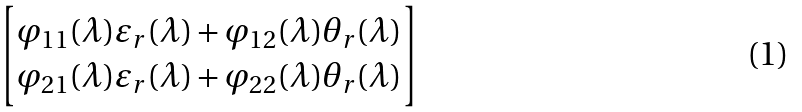Convert formula to latex. <formula><loc_0><loc_0><loc_500><loc_500>\begin{bmatrix} \varphi _ { 1 1 } ( \lambda ) \varepsilon _ { r } ( \lambda ) + \varphi _ { 1 2 } ( \lambda ) \theta _ { r } ( \lambda ) \\ \varphi _ { 2 1 } ( \lambda ) \varepsilon _ { r } ( \lambda ) + \varphi _ { 2 2 } ( \lambda ) \theta _ { r } ( \lambda ) \end{bmatrix}</formula> 